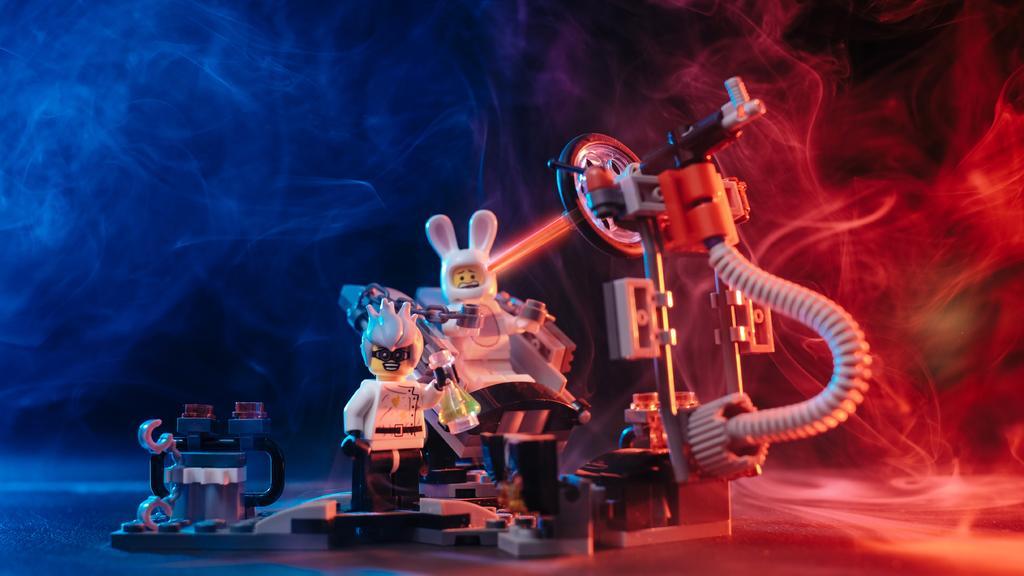Could you give a brief overview of what you see in this image? In this picture we can see few toys and smoke. 